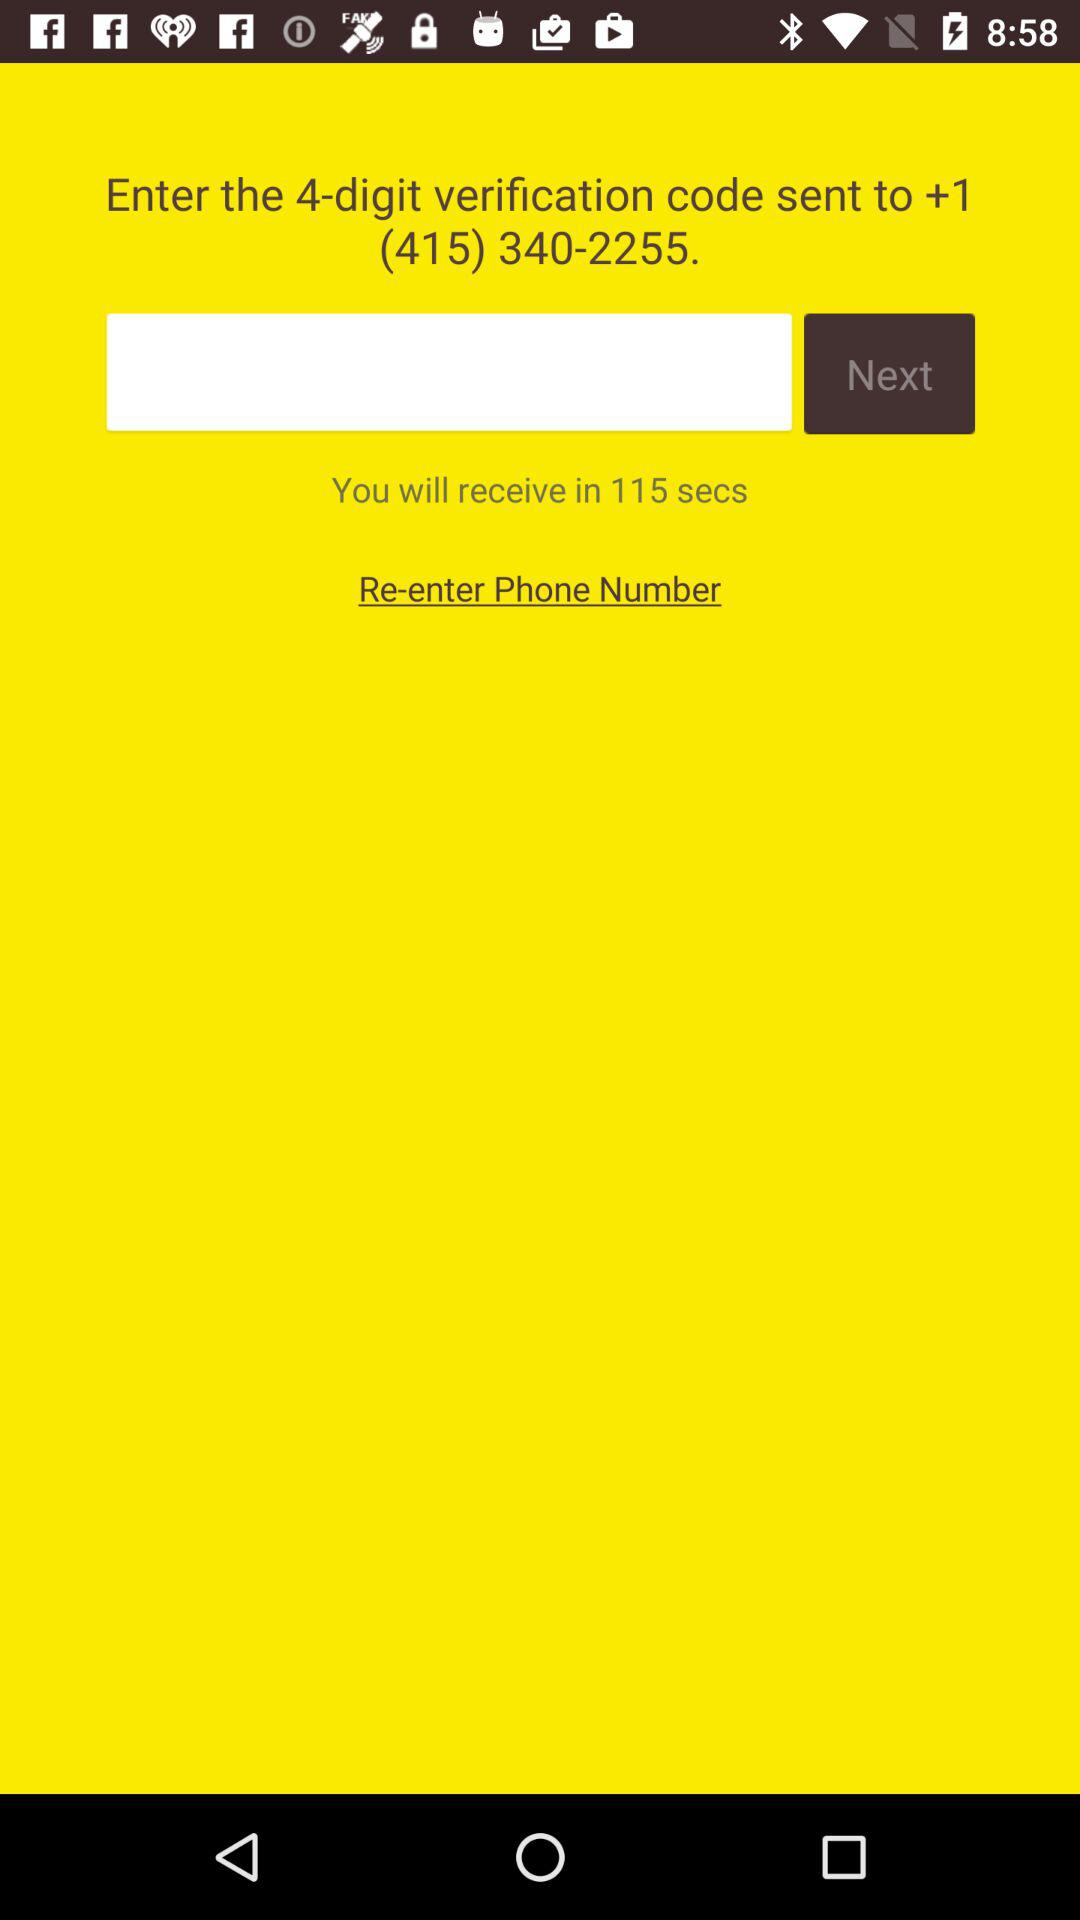How many digits are in the verification code? There are 4 digits in the verification code. 